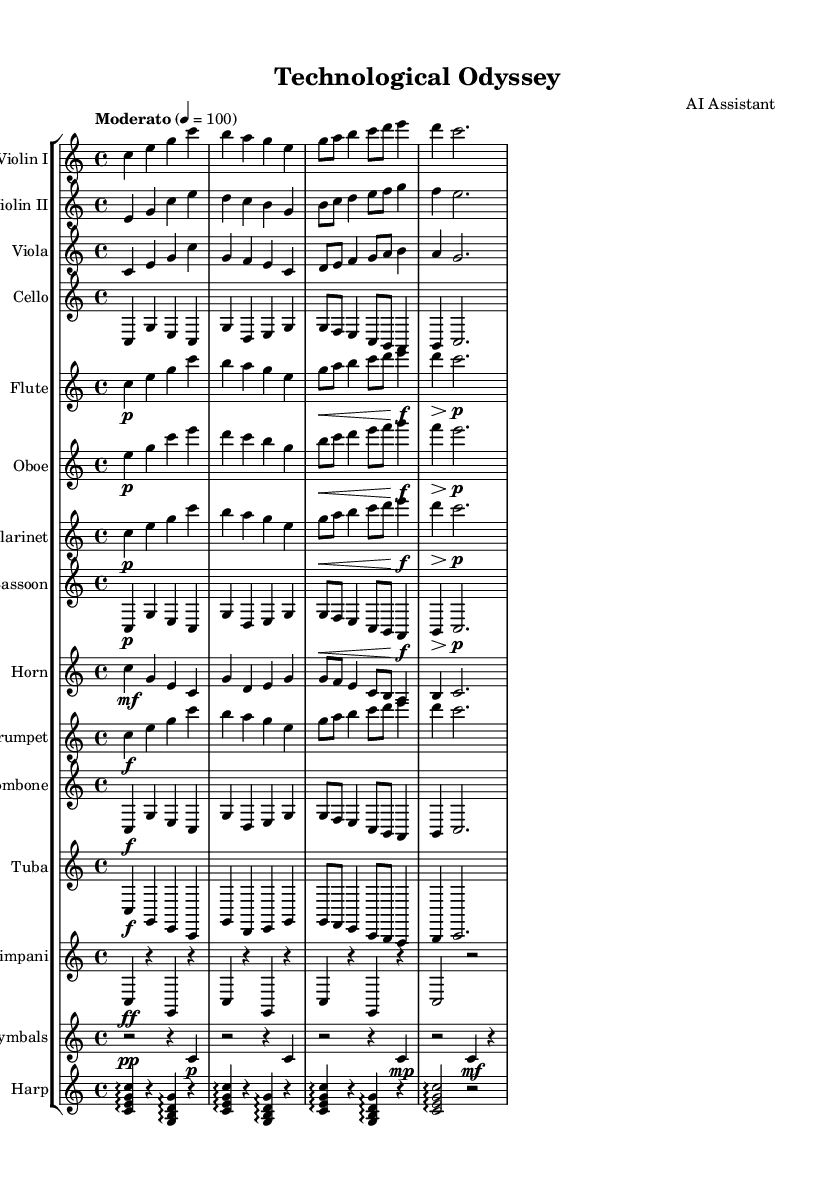What is the key signature of this music? The key signature is indicated in the beginning of the score. It shows that there are no sharps or flats before the notes, which corresponds to C major.
Answer: C major What is the time signature of this music? The time signature is found at the beginning of the score, represented as 4/4, which indicates four beats per measure and a quarter note receiving one beat.
Answer: 4/4 What is the tempo marking for this piece? The tempo marking is found in the score and indicates the speed of the music. It is listed as "Moderato" with a metronome marking of quarter note equals 100.
Answer: Moderato, 100 How many measures are there in the violin part? By counting the measures in the violin part provided in the score, there are a total of eight measures.
Answer: Eight Which instruments play the same melody at the beginning? The instruments that play the same melody at the beginning are Violin I and Violin II, as they have similar melodic lines indicated in the score.
Answer: Violin I and Violin II What dynamic marking is found for the flute's entry? The dynamic marking for the flute's entry, indicated at the beginning of the flute part, shows a piano marking (p), indicating a soft volume.
Answer: Piano What instruments are consistently marked with a forte dynamic? The instruments marked with a forte dynamic (f) throughout the piece include the Trumpet, Trombone, and Tuba, as noted at various points in their staves.
Answer: Trumpet, Trombone, Tuba 